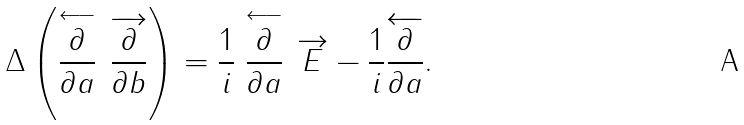<formula> <loc_0><loc_0><loc_500><loc_500>\Delta \left ( \stackrel { \longleftarrow } { \frac { \partial } { \partial a } } \, \overrightarrow { \frac { \partial } { \partial b } } \right ) = \frac { 1 } { i } \stackrel { \longleftarrow } { \frac { \partial } { \partial a } } \, \overrightarrow { E } - \frac { 1 } { i } \overleftarrow { \frac { \partial } { \partial a } } .</formula> 